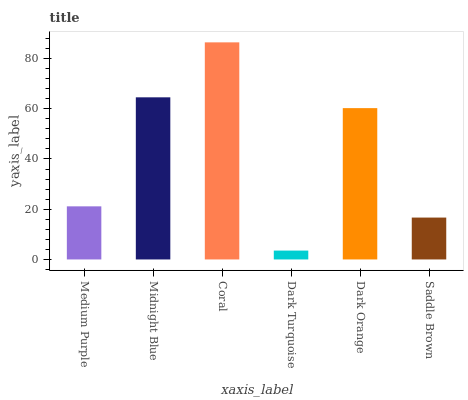Is Dark Turquoise the minimum?
Answer yes or no. Yes. Is Coral the maximum?
Answer yes or no. Yes. Is Midnight Blue the minimum?
Answer yes or no. No. Is Midnight Blue the maximum?
Answer yes or no. No. Is Midnight Blue greater than Medium Purple?
Answer yes or no. Yes. Is Medium Purple less than Midnight Blue?
Answer yes or no. Yes. Is Medium Purple greater than Midnight Blue?
Answer yes or no. No. Is Midnight Blue less than Medium Purple?
Answer yes or no. No. Is Dark Orange the high median?
Answer yes or no. Yes. Is Medium Purple the low median?
Answer yes or no. Yes. Is Dark Turquoise the high median?
Answer yes or no. No. Is Midnight Blue the low median?
Answer yes or no. No. 